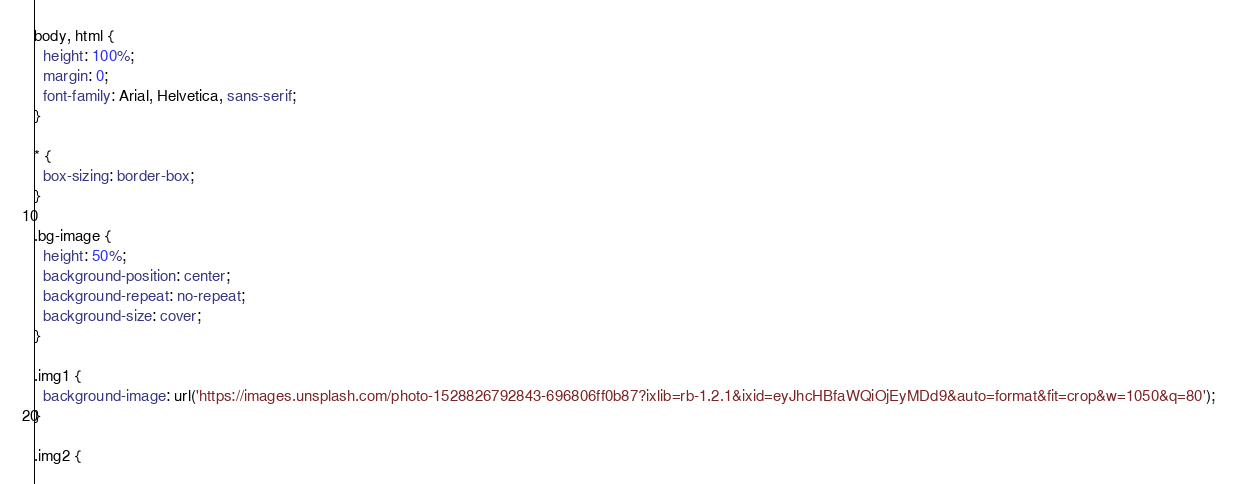Convert code to text. <code><loc_0><loc_0><loc_500><loc_500><_CSS_>body, html {
  height: 100%;
  margin: 0;
  font-family: Arial, Helvetica, sans-serif;
}

* {
  box-sizing: border-box;
}

.bg-image {
  height: 50%;
  background-position: center;
  background-repeat: no-repeat;
  background-size: cover;
}

.img1 {
  background-image: url('https://images.unsplash.com/photo-1528826792843-696806ff0b87?ixlib=rb-1.2.1&ixid=eyJhcHBfaWQiOjEyMDd9&auto=format&fit=crop&w=1050&q=80');
}

.img2 {</code> 